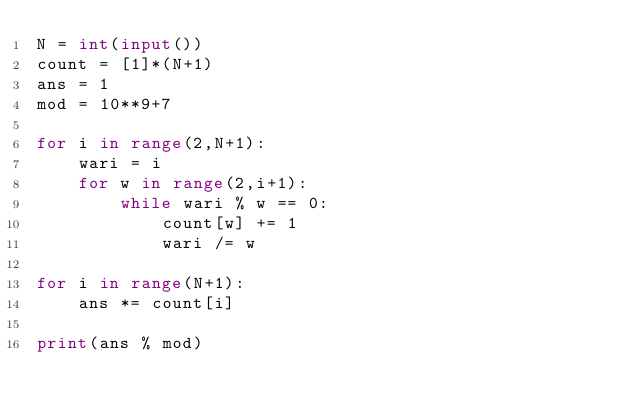<code> <loc_0><loc_0><loc_500><loc_500><_Python_>N = int(input())
count = [1]*(N+1)
ans = 1
mod = 10**9+7

for i in range(2,N+1):
    wari = i
    for w in range(2,i+1):
        while wari % w == 0:
            count[w] += 1
            wari /= w

for i in range(N+1):
    ans *= count[i]

print(ans % mod)</code> 